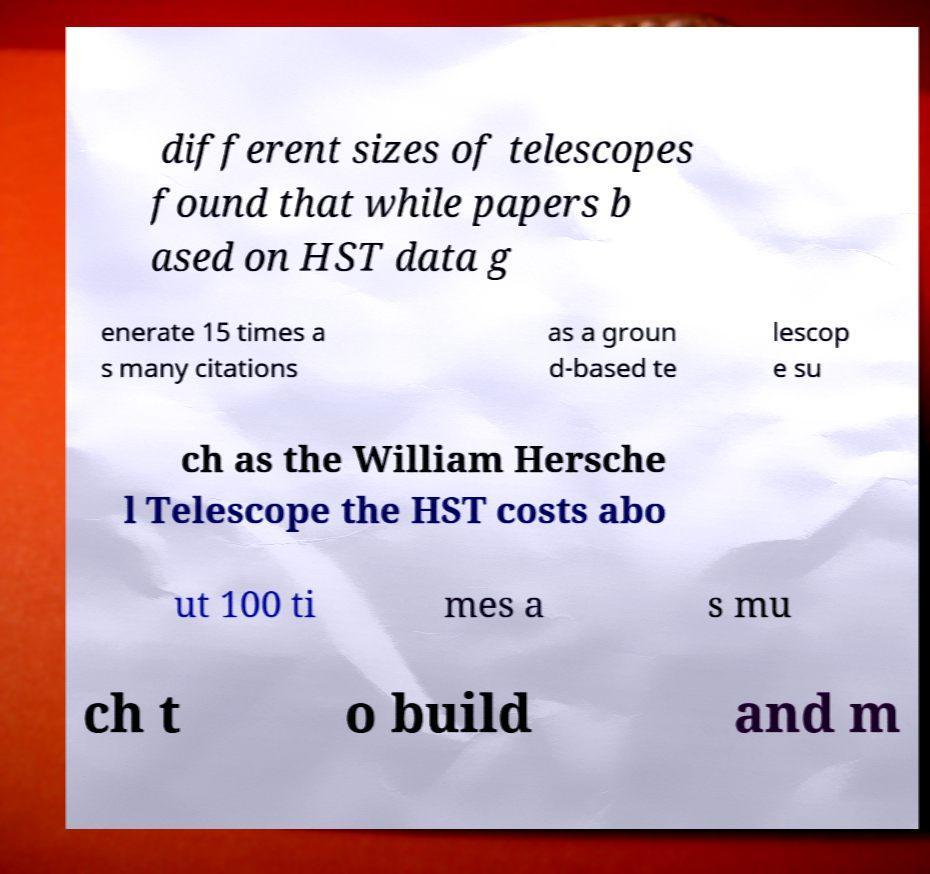Can you accurately transcribe the text from the provided image for me? different sizes of telescopes found that while papers b ased on HST data g enerate 15 times a s many citations as a groun d-based te lescop e su ch as the William Hersche l Telescope the HST costs abo ut 100 ti mes a s mu ch t o build and m 